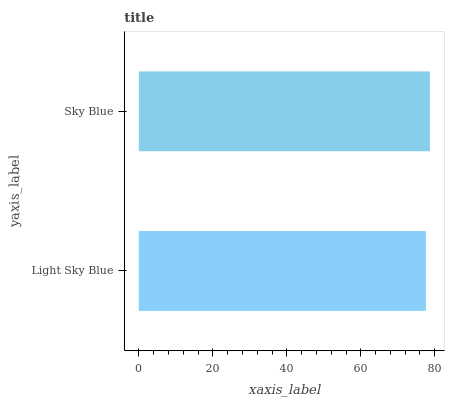Is Light Sky Blue the minimum?
Answer yes or no. Yes. Is Sky Blue the maximum?
Answer yes or no. Yes. Is Sky Blue the minimum?
Answer yes or no. No. Is Sky Blue greater than Light Sky Blue?
Answer yes or no. Yes. Is Light Sky Blue less than Sky Blue?
Answer yes or no. Yes. Is Light Sky Blue greater than Sky Blue?
Answer yes or no. No. Is Sky Blue less than Light Sky Blue?
Answer yes or no. No. Is Sky Blue the high median?
Answer yes or no. Yes. Is Light Sky Blue the low median?
Answer yes or no. Yes. Is Light Sky Blue the high median?
Answer yes or no. No. Is Sky Blue the low median?
Answer yes or no. No. 